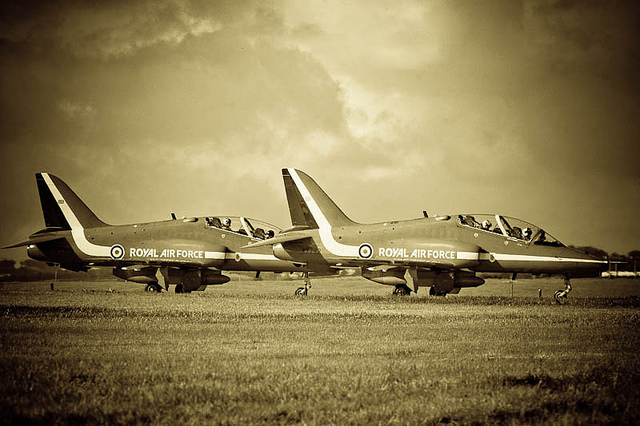Please identify all text content in this image. ROYAL AIR FORCE ROYAL AIR FORCE 